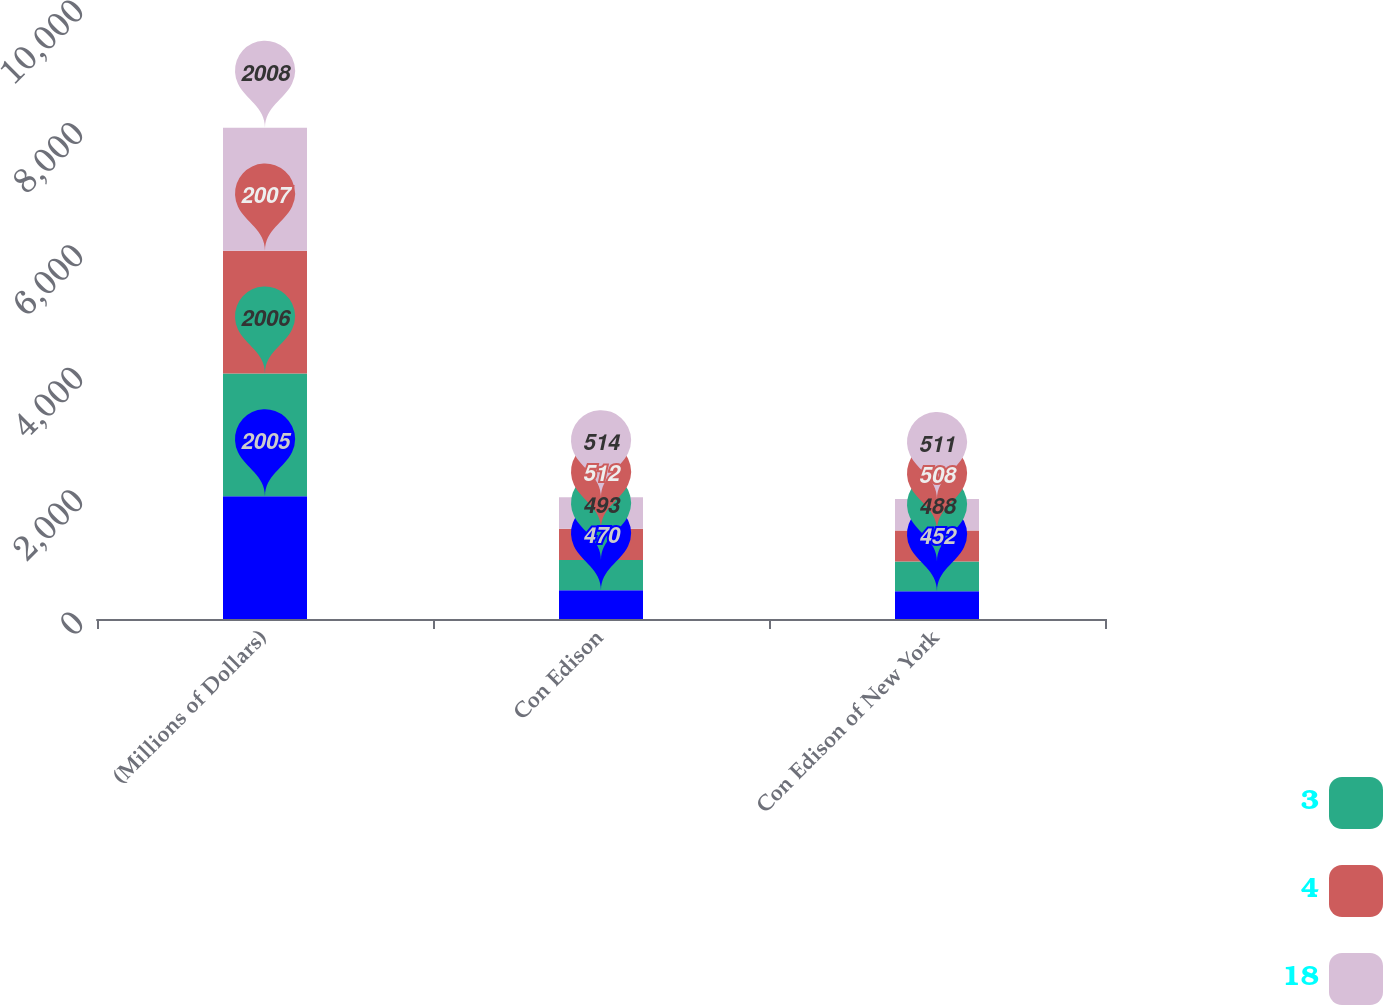<chart> <loc_0><loc_0><loc_500><loc_500><stacked_bar_chart><ecel><fcel>(Millions of Dollars)<fcel>Con Edison<fcel>Con Edison of New York<nl><fcel>nan<fcel>2005<fcel>470<fcel>452<nl><fcel>3<fcel>2006<fcel>493<fcel>488<nl><fcel>4<fcel>2007<fcel>512<fcel>508<nl><fcel>18<fcel>2008<fcel>514<fcel>511<nl></chart> 